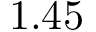Convert formula to latex. <formula><loc_0><loc_0><loc_500><loc_500>1 . 4 5</formula> 